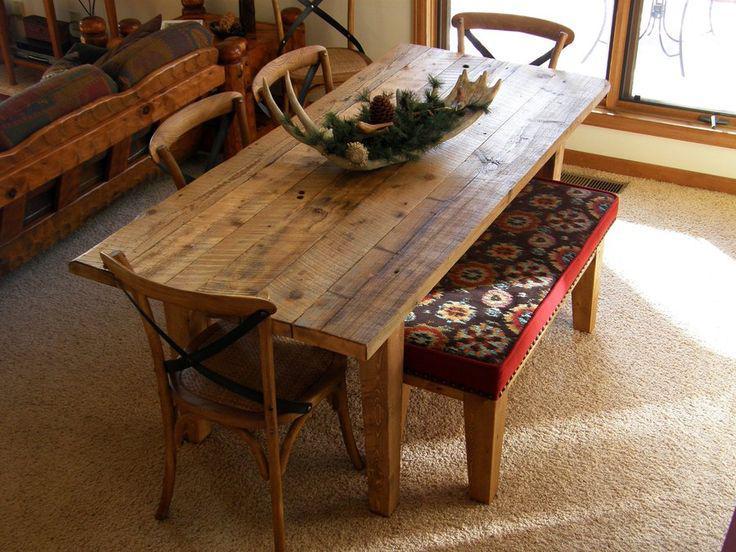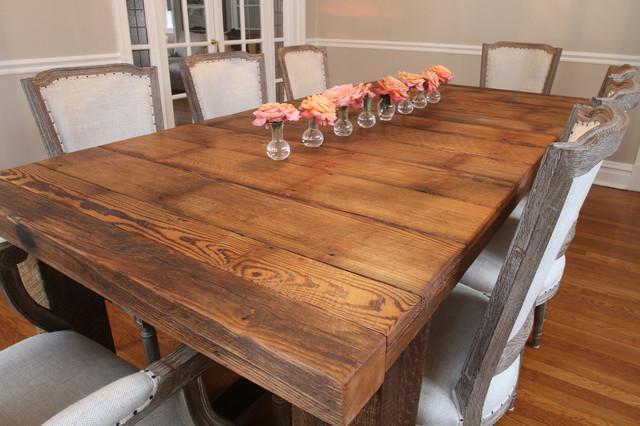The first image is the image on the left, the second image is the image on the right. For the images shown, is this caption "there are flowers on the table in the image on the right" true? Answer yes or no. Yes. The first image is the image on the left, the second image is the image on the right. Considering the images on both sides, is "In one image, a table has both chair and bench seating." valid? Answer yes or no. Yes. 